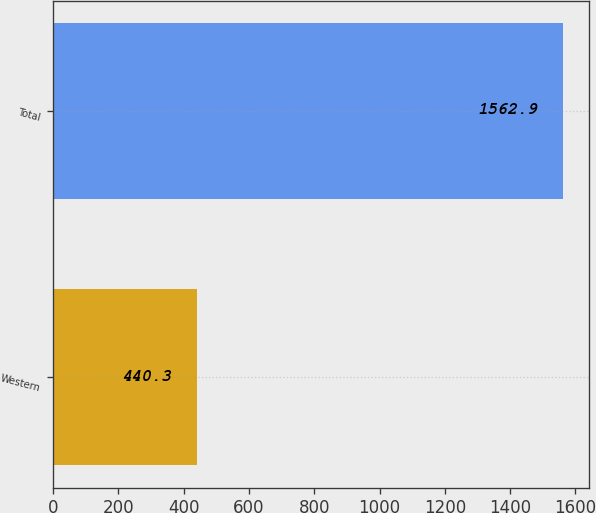<chart> <loc_0><loc_0><loc_500><loc_500><bar_chart><fcel>Western<fcel>Total<nl><fcel>440.3<fcel>1562.9<nl></chart> 